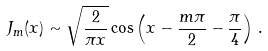<formula> <loc_0><loc_0><loc_500><loc_500>J _ { m } ( x ) \sim \sqrt { \frac { 2 } { \pi x } } \cos \left ( x - \frac { m \pi } { 2 } - \frac { \pi } { 4 } \right ) \, .</formula> 